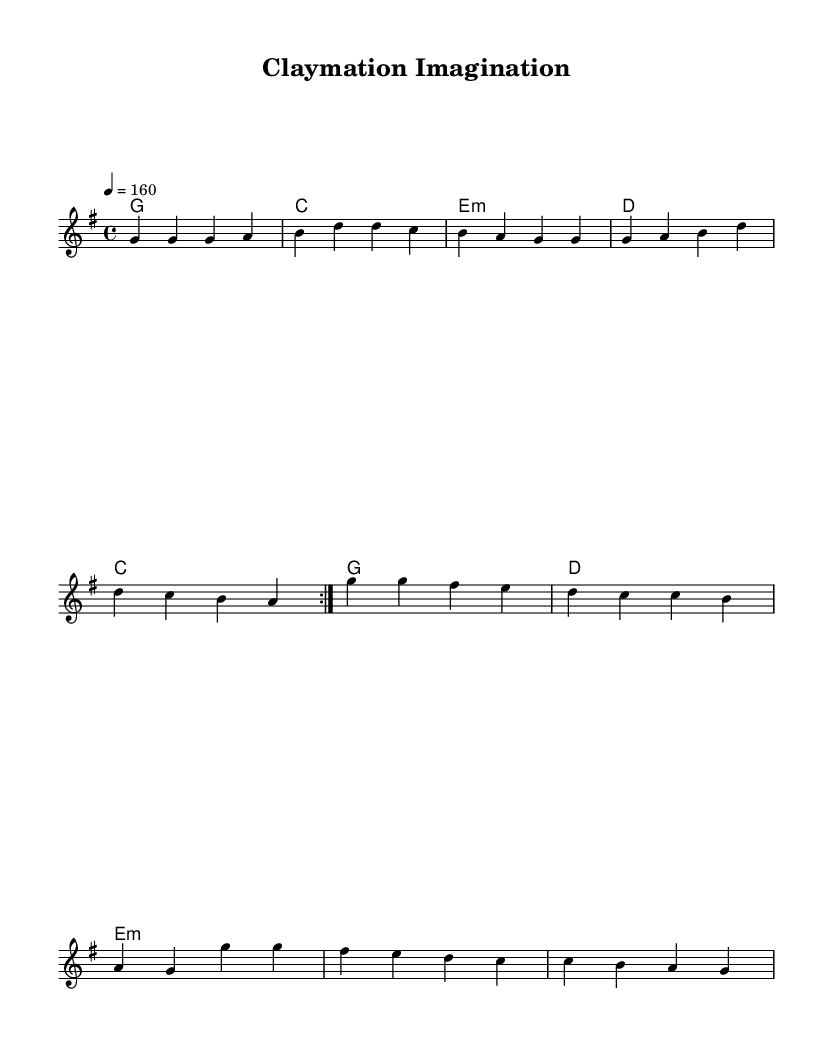What is the key signature of this music? The key signature is indicated at the beginning of the score, where it shows one sharp, indicating it is in G major.
Answer: G major What is the time signature of this music? The time signature is found at the beginning of the score and is written as a fraction, here showing 4 over 4, meaning four beats per measure.
Answer: 4/4 What is the tempo marking of this piece? The tempo marking is provided as a number at the start of the music, indicating how fast the piece should be played. Here, it is marked as 160 beats per minute.
Answer: 160 How many measures are in the verse section? By counting the bar lines (vertical lines) in the verse section, there are five measures present before the chorus begins.
Answer: 5 What type of harmony is primarily used in this piece? The harmonies are structured in a chord progression typical for punk, using basic triads and seventh chords. Upon review, simple chords like G, C, D, and E minor are present.
Answer: Triads How many times is the verse repeated before the chorus? The sheet music shows a repeat indication (volta), indicating that the verse is played two times before the chorus section.
Answer: 2 What themes do the lyrics of the chorus reflect in relation to animation? The chorus lyrics center around creativity and the process of animating, emphasizing themes like molding dreams and the rebellious nature of claymation art.
Answer: Creativity and rebellion 